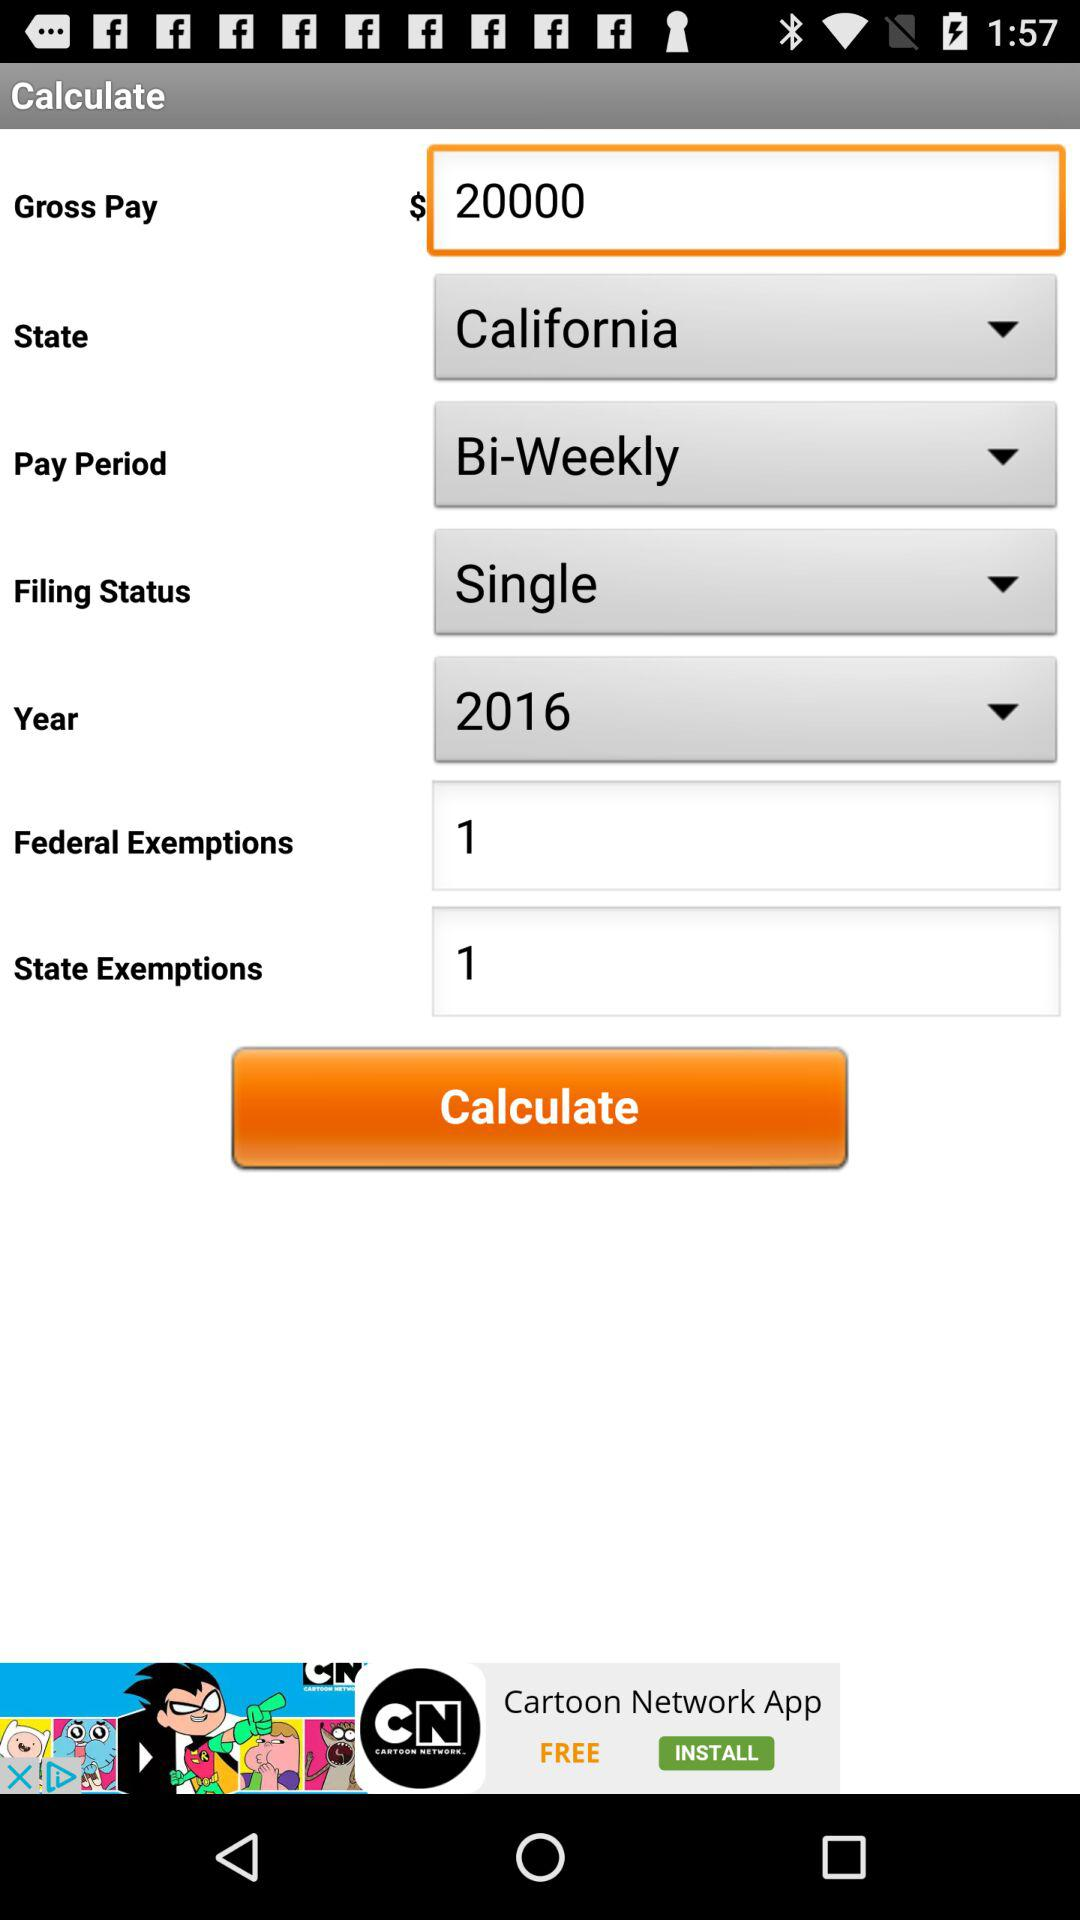How much are the federal and state exemptions combined?
Answer the question using a single word or phrase. 2 